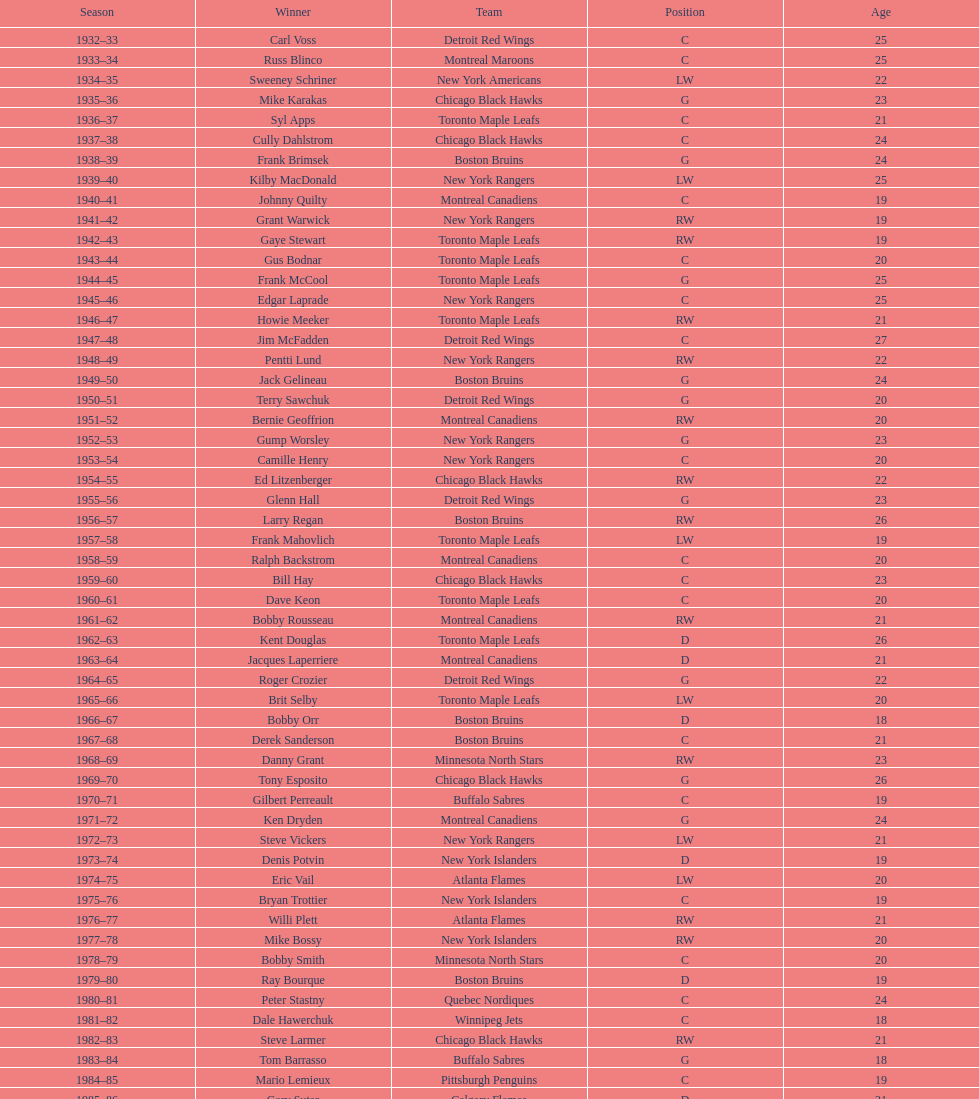Could you help me parse every detail presented in this table? {'header': ['Season', 'Winner', 'Team', 'Position', 'Age'], 'rows': [['1932–33', 'Carl Voss', 'Detroit Red Wings', 'C', '25'], ['1933–34', 'Russ Blinco', 'Montreal Maroons', 'C', '25'], ['1934–35', 'Sweeney Schriner', 'New York Americans', 'LW', '22'], ['1935–36', 'Mike Karakas', 'Chicago Black Hawks', 'G', '23'], ['1936–37', 'Syl Apps', 'Toronto Maple Leafs', 'C', '21'], ['1937–38', 'Cully Dahlstrom', 'Chicago Black Hawks', 'C', '24'], ['1938–39', 'Frank Brimsek', 'Boston Bruins', 'G', '24'], ['1939–40', 'Kilby MacDonald', 'New York Rangers', 'LW', '25'], ['1940–41', 'Johnny Quilty', 'Montreal Canadiens', 'C', '19'], ['1941–42', 'Grant Warwick', 'New York Rangers', 'RW', '19'], ['1942–43', 'Gaye Stewart', 'Toronto Maple Leafs', 'RW', '19'], ['1943–44', 'Gus Bodnar', 'Toronto Maple Leafs', 'C', '20'], ['1944–45', 'Frank McCool', 'Toronto Maple Leafs', 'G', '25'], ['1945–46', 'Edgar Laprade', 'New York Rangers', 'C', '25'], ['1946–47', 'Howie Meeker', 'Toronto Maple Leafs', 'RW', '21'], ['1947–48', 'Jim McFadden', 'Detroit Red Wings', 'C', '27'], ['1948–49', 'Pentti Lund', 'New York Rangers', 'RW', '22'], ['1949–50', 'Jack Gelineau', 'Boston Bruins', 'G', '24'], ['1950–51', 'Terry Sawchuk', 'Detroit Red Wings', 'G', '20'], ['1951–52', 'Bernie Geoffrion', 'Montreal Canadiens', 'RW', '20'], ['1952–53', 'Gump Worsley', 'New York Rangers', 'G', '23'], ['1953–54', 'Camille Henry', 'New York Rangers', 'C', '20'], ['1954–55', 'Ed Litzenberger', 'Chicago Black Hawks', 'RW', '22'], ['1955–56', 'Glenn Hall', 'Detroit Red Wings', 'G', '23'], ['1956–57', 'Larry Regan', 'Boston Bruins', 'RW', '26'], ['1957–58', 'Frank Mahovlich', 'Toronto Maple Leafs', 'LW', '19'], ['1958–59', 'Ralph Backstrom', 'Montreal Canadiens', 'C', '20'], ['1959–60', 'Bill Hay', 'Chicago Black Hawks', 'C', '23'], ['1960–61', 'Dave Keon', 'Toronto Maple Leafs', 'C', '20'], ['1961–62', 'Bobby Rousseau', 'Montreal Canadiens', 'RW', '21'], ['1962–63', 'Kent Douglas', 'Toronto Maple Leafs', 'D', '26'], ['1963–64', 'Jacques Laperriere', 'Montreal Canadiens', 'D', '21'], ['1964–65', 'Roger Crozier', 'Detroit Red Wings', 'G', '22'], ['1965–66', 'Brit Selby', 'Toronto Maple Leafs', 'LW', '20'], ['1966–67', 'Bobby Orr', 'Boston Bruins', 'D', '18'], ['1967–68', 'Derek Sanderson', 'Boston Bruins', 'C', '21'], ['1968–69', 'Danny Grant', 'Minnesota North Stars', 'RW', '23'], ['1969–70', 'Tony Esposito', 'Chicago Black Hawks', 'G', '26'], ['1970–71', 'Gilbert Perreault', 'Buffalo Sabres', 'C', '19'], ['1971–72', 'Ken Dryden', 'Montreal Canadiens', 'G', '24'], ['1972–73', 'Steve Vickers', 'New York Rangers', 'LW', '21'], ['1973–74', 'Denis Potvin', 'New York Islanders', 'D', '19'], ['1974–75', 'Eric Vail', 'Atlanta Flames', 'LW', '20'], ['1975–76', 'Bryan Trottier', 'New York Islanders', 'C', '19'], ['1976–77', 'Willi Plett', 'Atlanta Flames', 'RW', '21'], ['1977–78', 'Mike Bossy', 'New York Islanders', 'RW', '20'], ['1978–79', 'Bobby Smith', 'Minnesota North Stars', 'C', '20'], ['1979–80', 'Ray Bourque', 'Boston Bruins', 'D', '19'], ['1980–81', 'Peter Stastny', 'Quebec Nordiques', 'C', '24'], ['1981–82', 'Dale Hawerchuk', 'Winnipeg Jets', 'C', '18'], ['1982–83', 'Steve Larmer', 'Chicago Black Hawks', 'RW', '21'], ['1983–84', 'Tom Barrasso', 'Buffalo Sabres', 'G', '18'], ['1984–85', 'Mario Lemieux', 'Pittsburgh Penguins', 'C', '19'], ['1985–86', 'Gary Suter', 'Calgary Flames', 'D', '21'], ['1986–87', 'Luc Robitaille', 'Los Angeles Kings', 'LW', '20'], ['1987–88', 'Joe Nieuwendyk', 'Calgary Flames', 'C', '21'], ['1988–89', 'Brian Leetch', 'New York Rangers', 'D', '20'], ['1989–90', 'Sergei Makarov', 'Calgary Flames', 'RW', '31'], ['1990–91', 'Ed Belfour', 'Chicago Blackhawks', 'G', '25'], ['1991–92', 'Pavel Bure', 'Vancouver Canucks', 'RW', '20'], ['1992–93', 'Teemu Selanne', 'Winnipeg Jets', 'RW', '22'], ['1993–94', 'Martin Brodeur', 'New Jersey Devils', 'G', '21'], ['1994–95', 'Peter Forsberg', 'Quebec Nordiques', 'C', '21'], ['1995–96', 'Daniel Alfredsson', 'Ottawa Senators', 'RW', '22'], ['1996–97', 'Bryan Berard', 'New York Islanders', 'D', '19'], ['1997–98', 'Sergei Samsonov', 'Boston Bruins', 'LW', '19'], ['1998–99', 'Chris Drury', 'Colorado Avalanche', 'C', '22'], ['1999–2000', 'Scott Gomez', 'New Jersey Devils', 'C', '19'], ['2000–01', 'Evgeni Nabokov', 'San Jose Sharks', 'G', '25'], ['2001–02', 'Dany Heatley', 'Atlanta Thrashers', 'RW', '20'], ['2002–03', 'Barret Jackman', 'St. Louis Blues', 'D', '21'], ['2003–04', 'Andrew Raycroft', 'Boston Bruins', 'G', '23'], ['2004–05', 'No winner because of the\\n2004–05 NHL lockout', '-', '-', '-'], ['2005–06', 'Alexander Ovechkin', 'Washington Capitals', 'LW', '20'], ['2006–07', 'Evgeni Malkin', 'Pittsburgh Penguins', 'C', '20'], ['2007–08', 'Patrick Kane', 'Chicago Blackhawks', 'RW', '19'], ['2008–09', 'Steve Mason', 'Columbus Blue Jackets', 'G', '21'], ['2009–10', 'Tyler Myers', 'Buffalo Sabres', 'D', '20'], ['2010–11', 'Jeff Skinner', 'Carolina Hurricanes', 'C', '18'], ['2011–12', 'Gabriel Landeskog', 'Colorado Avalanche', 'LW', '19'], ['2012–13', 'Jonathan Huberdeau', 'Florida Panthers', 'C', '19']]} How many times did the toronto maple leaves win? 9. 